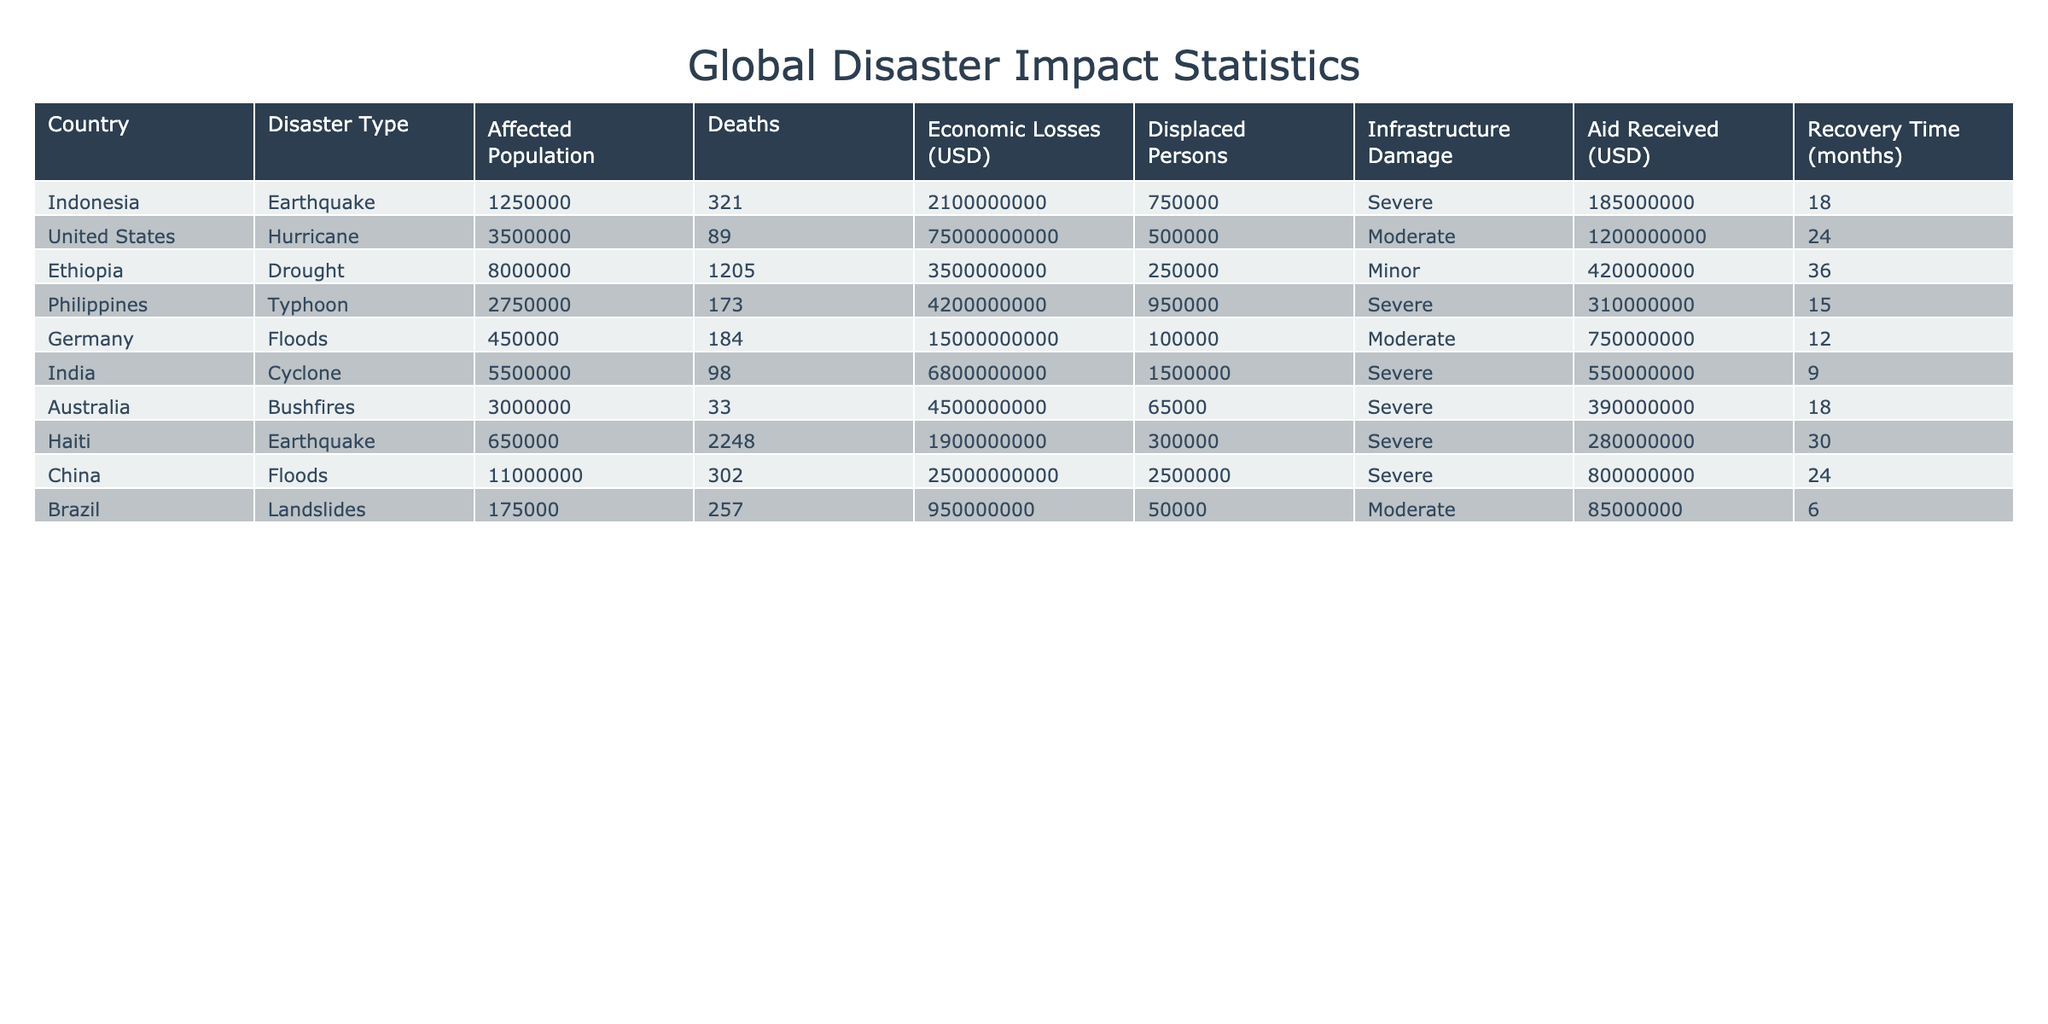What is the total affected population from all disasters listed? To find the total affected population, sum the affected populations of all the countries from the table: 1250000 + 3500000 + 8000000 + 2750000 + 450000 + 5500000 + 3000000 + 650000 + 11000000 + 175000 = 30625000.
Answer: 30625000 Which disaster resulted in the highest economic losses? By examining the "Economic Losses (USD)" column, it is clear that the United States hurricane caused the most significant economic losses amounting to 75000000000 USD.
Answer: United States Hurricane How many deaths were caused by droughts compared to floods? Counting deaths from the table: Droughts (Ethiopia) caused 1205 deaths, and Floods (Germany and China) caused a total of 184 + 302 = 486 deaths. Therefore, droughts caused more deaths (1205 > 486).
Answer: Droughts caused more deaths What is the average recovery time for all disasters listed? Calculate the recovery time for each disaster: (18 + 24 + 36 + 15 + 12 + 9 + 18 + 30 + 24 + 6) = 192 months. Then divide by the number of disasters (10): 192/10 = 19.2 months.
Answer: 19.2 months Is the aid received for the earthquake in Haiti greater than that for the floods in China? The aid received for Haiti is 280000000 USD, and for floods in China is 800000000 USD. Since 280000000 < 800000000, it confirms that the aid for Haiti is less.
Answer: No Which disaster had the greatest number of displaced persons? Referring to the "Displaced Persons" column, the cyclone in India resulted in the highest number of displaced persons, totaling 1500000.
Answer: Cyclone in India How many more deaths were caused by the earthquake in Haiti compared to the cyclone in India? Deaths were 2248 for Haiti and 98 for India. The difference is 2248 - 98 = 2150.
Answer: 2150 more deaths Which type of disaster had the greatest economic loss on average? Calculate average losses per disaster type: (Earthquake: (2100000000 + 1900000000) / 2 = 2000000000), (Hurricane: 75000000000), (Drought: 3500000000), (Typhoon: 4200000000), (Floods: 15000000000 + 25000000000 / 2 = 20000000000), (Cyclone: 6800000000), (Bushfires: 4500000000), (Landslides: 950000000). Hurricane has the highest at 75000000000.
Answer: Hurricane What percentage of the affected population in the Philippines is displaced? The affected population in the Philippines is 2750000, and the displaced persons are 950000. The percentage is (950000 / 2750000) * 100 = 34.55%.
Answer: 34.55% What is the total economic loss from all disasters involving marked infrastructure damage? Identify disasters with "Severe" infrastructure damage: Earthquake in Indonesia, Typhoon in Philippines, Cyclone in India, Earthquake in Haiti, Floods in China. Sum losses: 2100000000 + 4200000000 + 6800000000 + 1900000000 + 25000000000 = 36300000000.
Answer: 36300000000 